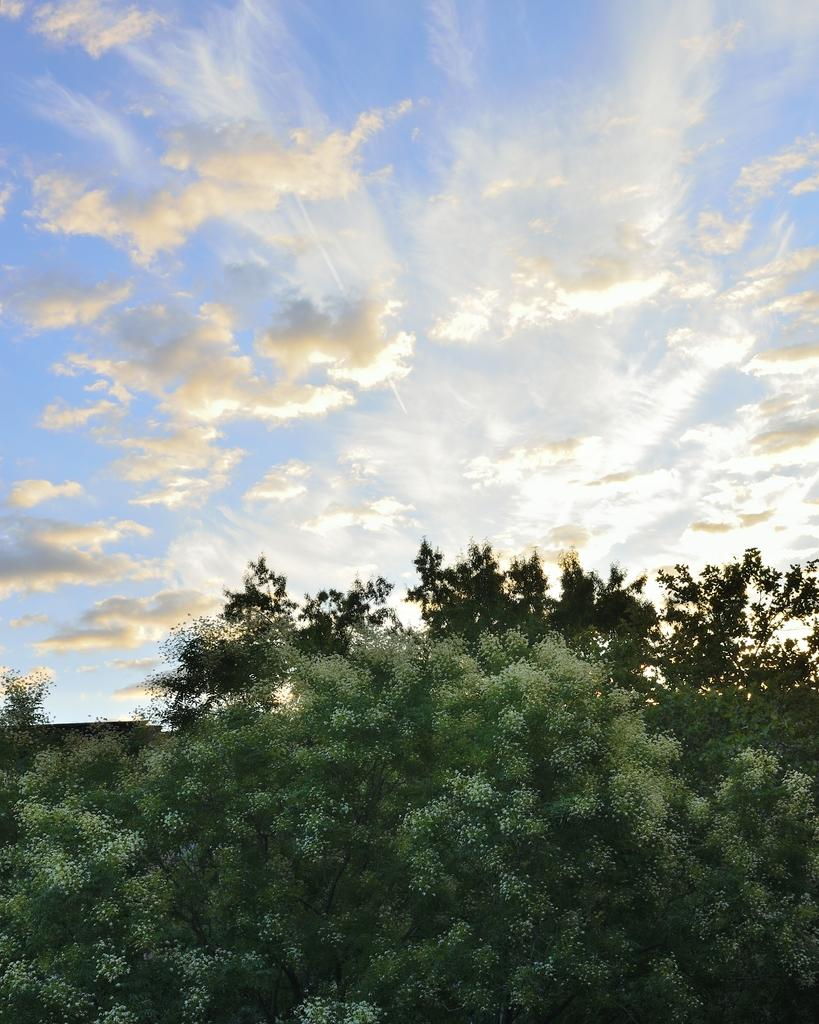What type of vegetation can be seen in the image? There are trees in the image. What part of the natural environment is visible in the image? The sky is visible in the image. What type of force can be seen pushing the trees in the image? There is no force pushing the trees in the image; they are stationary. How many babies are visible in the image? There are no babies present in the image. 